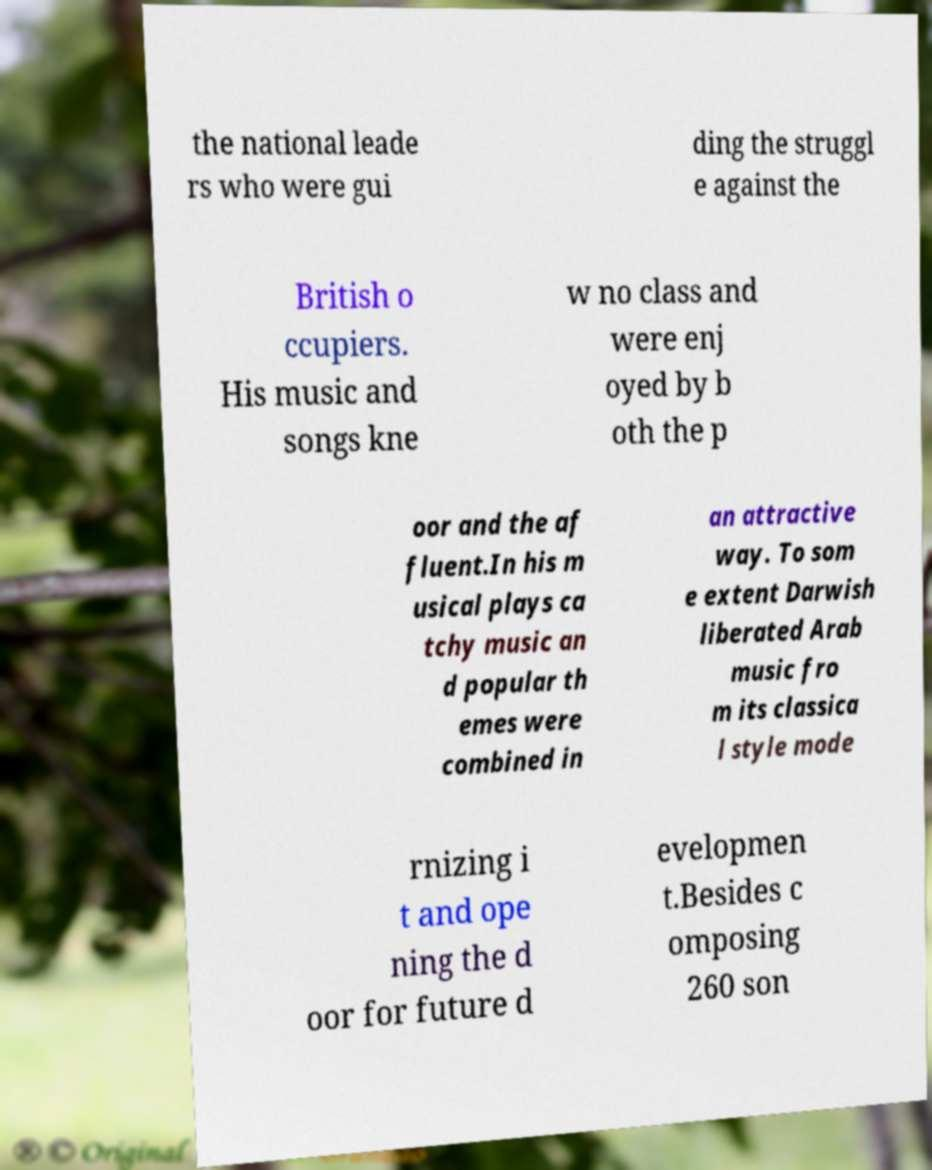I need the written content from this picture converted into text. Can you do that? the national leade rs who were gui ding the struggl e against the British o ccupiers. His music and songs kne w no class and were enj oyed by b oth the p oor and the af fluent.In his m usical plays ca tchy music an d popular th emes were combined in an attractive way. To som e extent Darwish liberated Arab music fro m its classica l style mode rnizing i t and ope ning the d oor for future d evelopmen t.Besides c omposing 260 son 